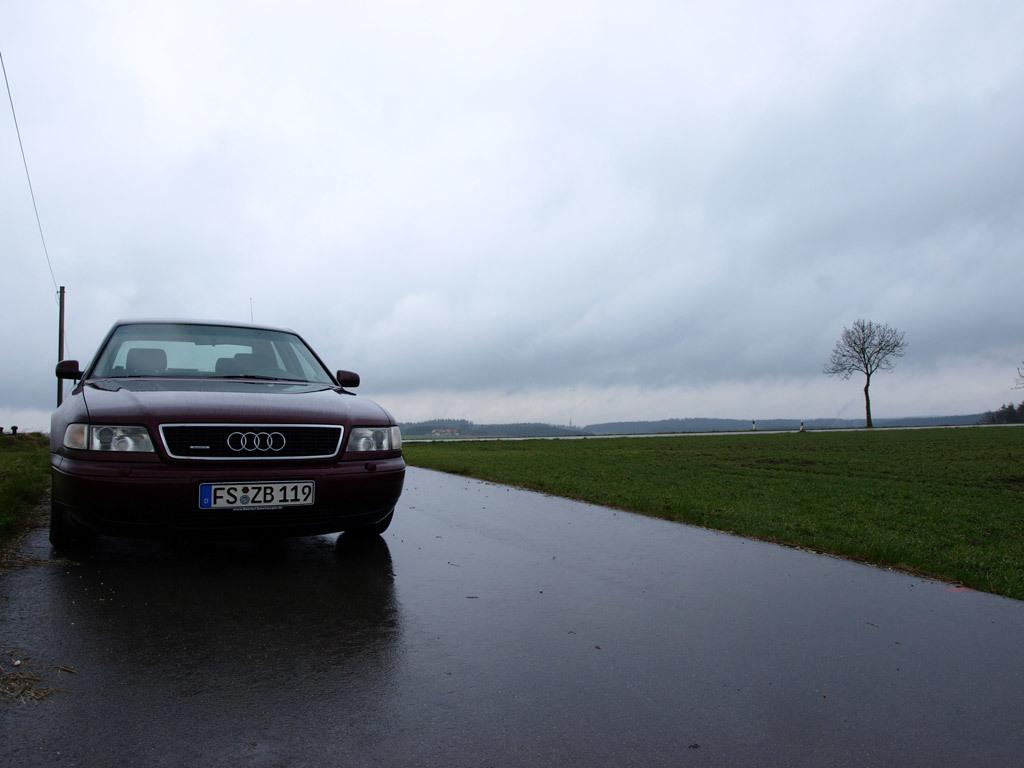<image>
Write a terse but informative summary of the picture. A red car with the license plate FS ZB 119. 